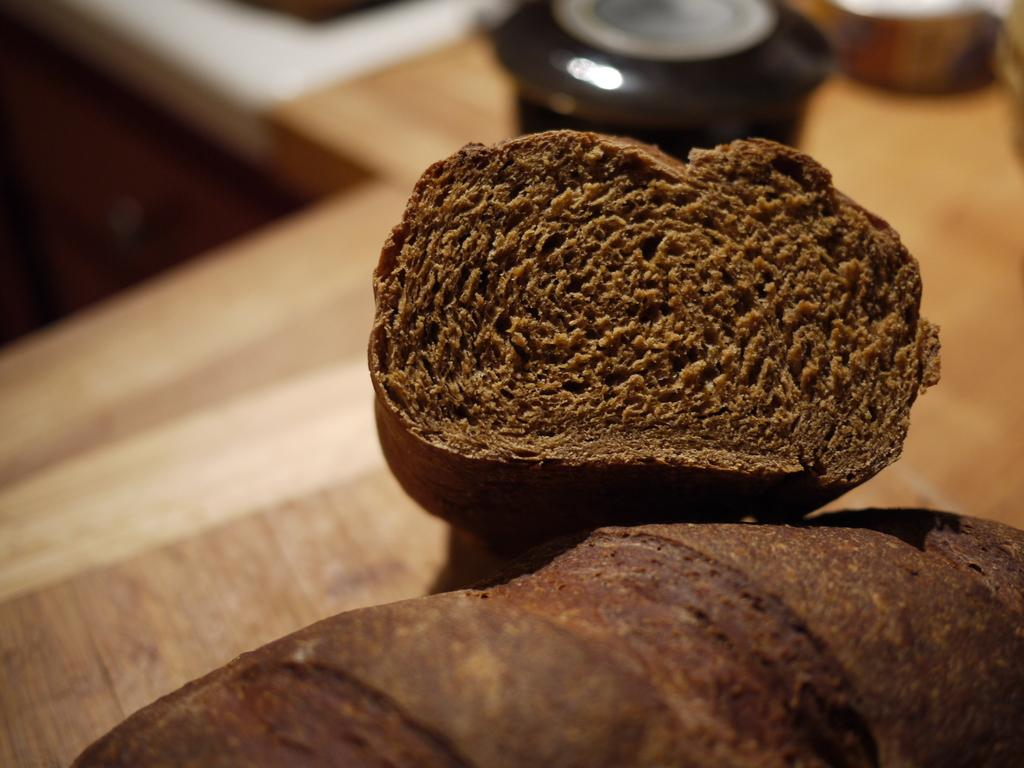What type of food item is visible in the image? The food item is brown in color. Can you describe the color of the food item? The food item is brown in color. What else can be seen in the background of the image? There are utensils on a surface in the background of the image. How many islands can be seen in the image? There are no islands present in the image. What part of the body is associated with the bit mentioned in the image? There is no mention of a bit or any body part in the image. 